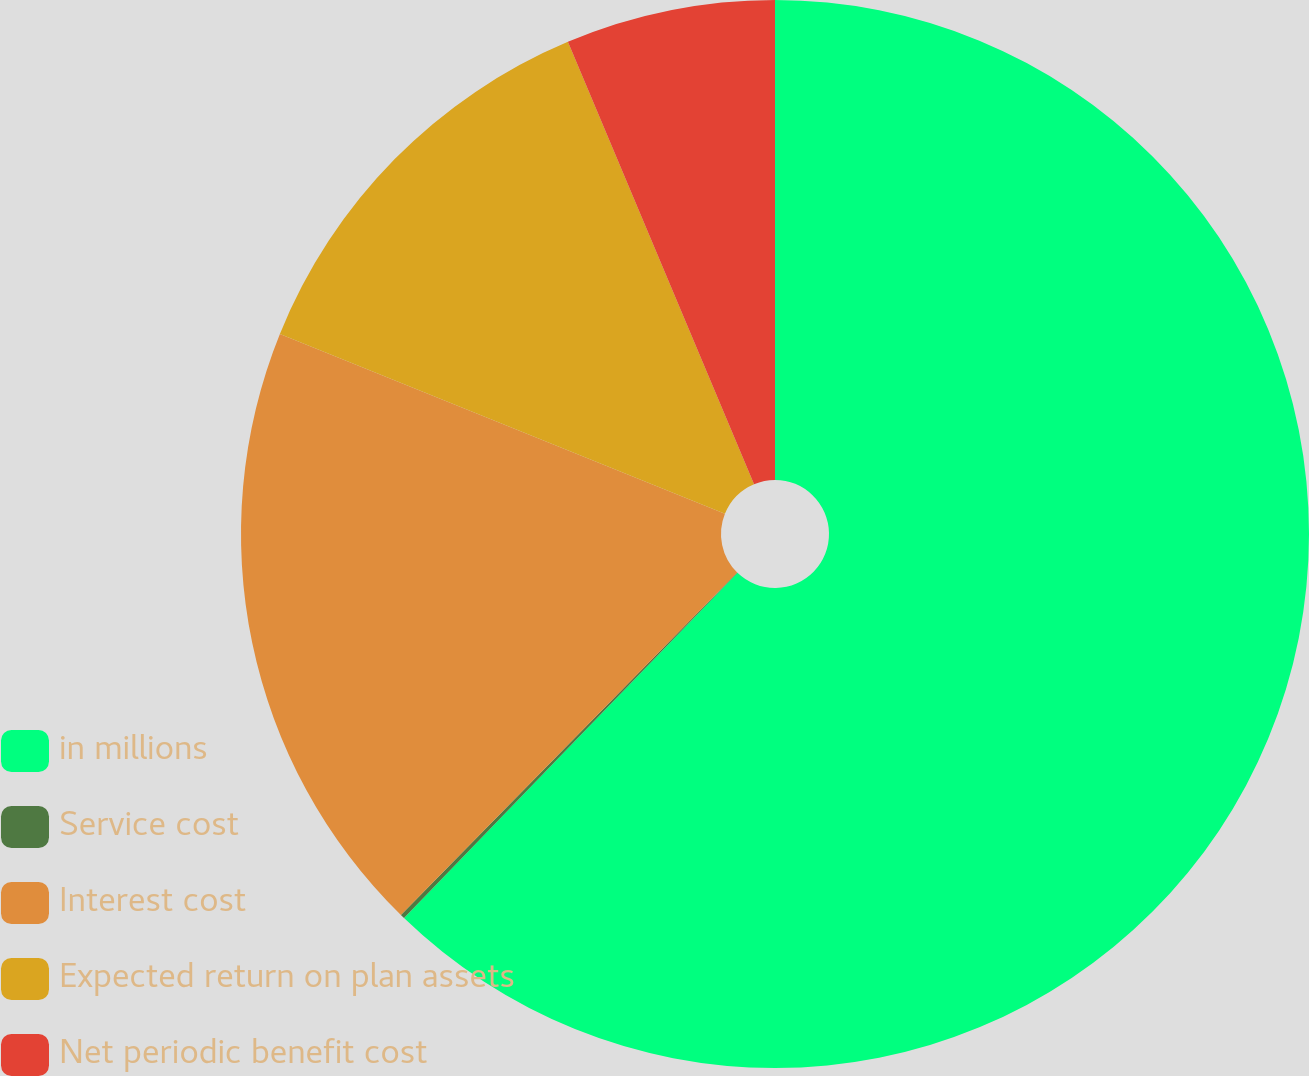<chart> <loc_0><loc_0><loc_500><loc_500><pie_chart><fcel>in millions<fcel>Service cost<fcel>Interest cost<fcel>Expected return on plan assets<fcel>Net periodic benefit cost<nl><fcel>62.23%<fcel>0.13%<fcel>18.76%<fcel>12.55%<fcel>6.34%<nl></chart> 